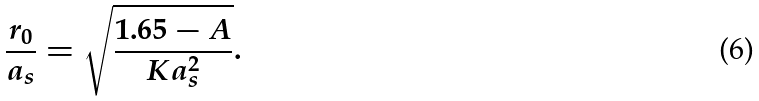<formula> <loc_0><loc_0><loc_500><loc_500>\frac { r _ { 0 } } { a _ { s } } = \sqrt { \frac { 1 . 6 5 - A } { K a _ { s } ^ { 2 } } } .</formula> 